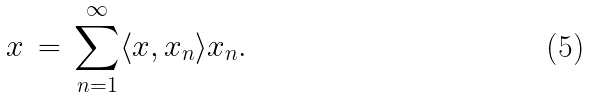<formula> <loc_0><loc_0><loc_500><loc_500>x \, = \, \sum _ { n = 1 } ^ { \infty } \langle x , x _ { n } \rangle x _ { n } .</formula> 